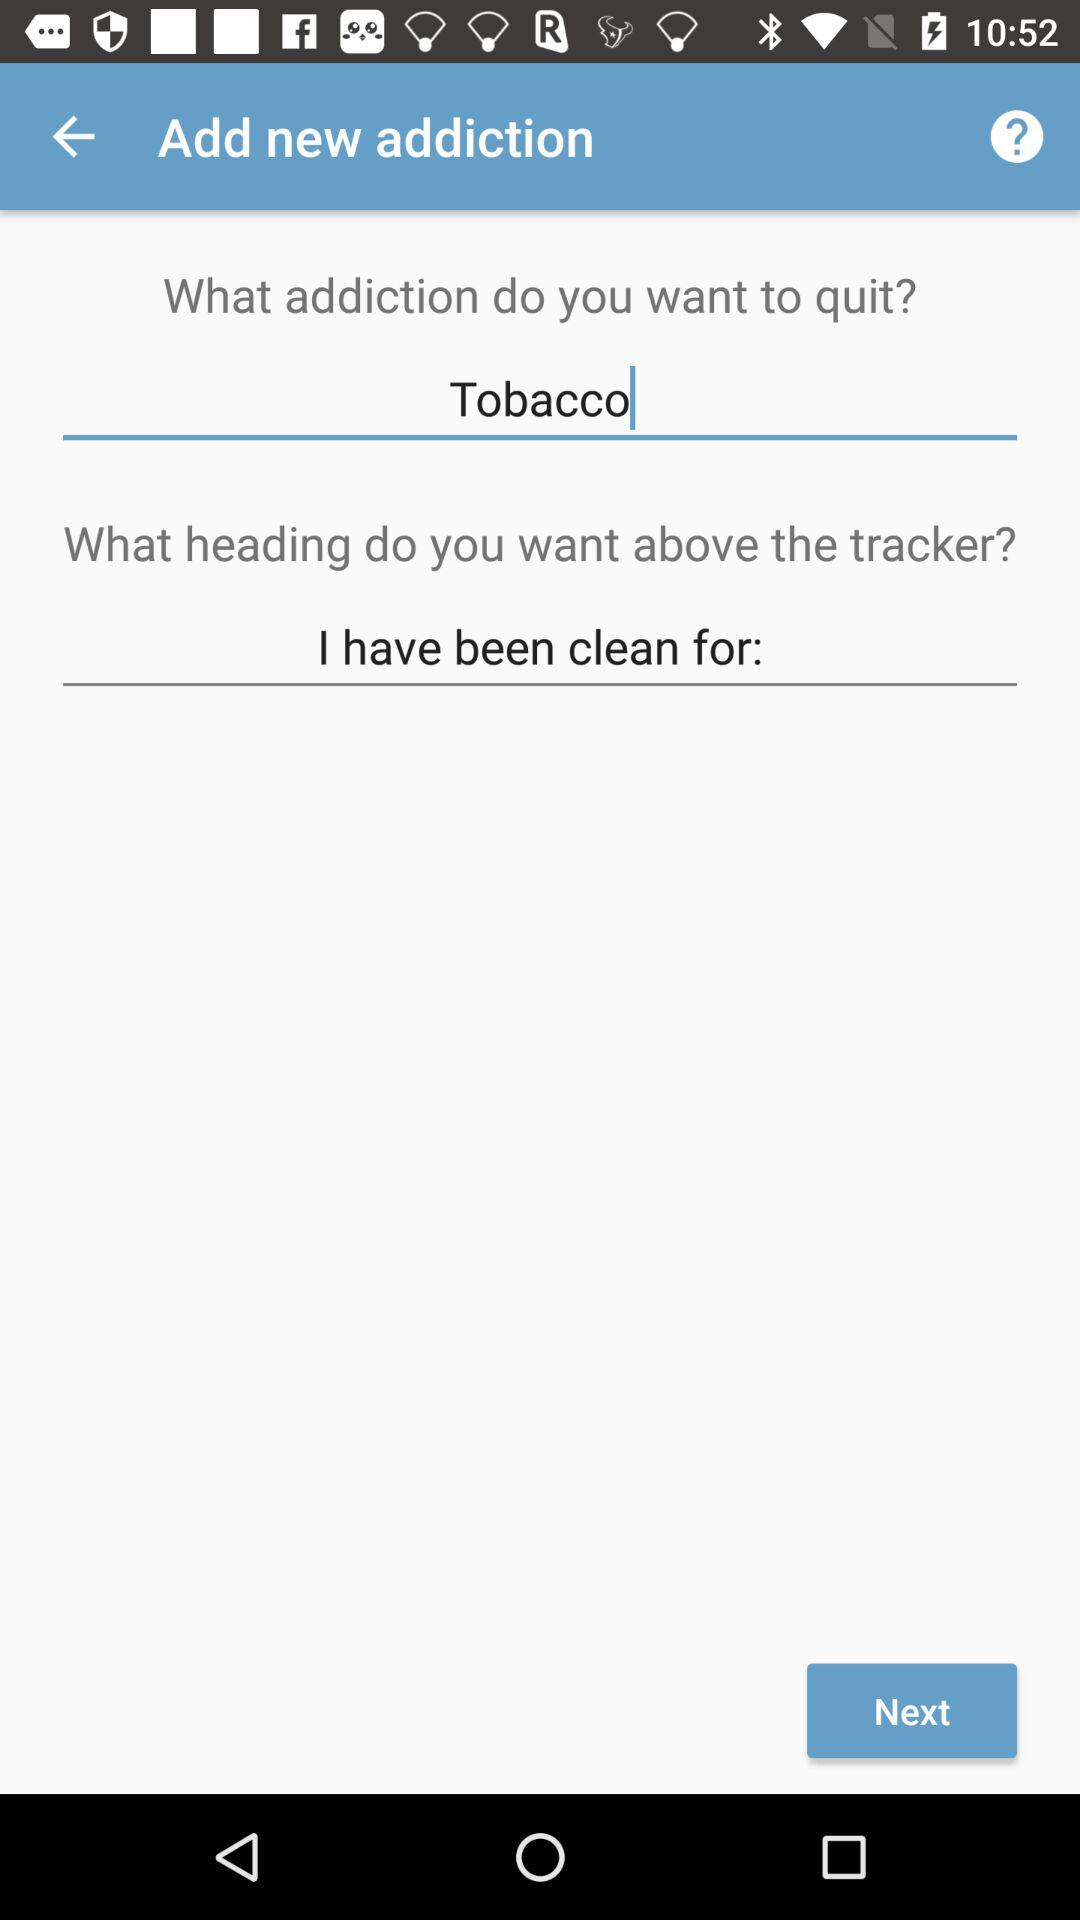What addiction do I want to get rid of? You want to get rid of your tobacco addiction. 